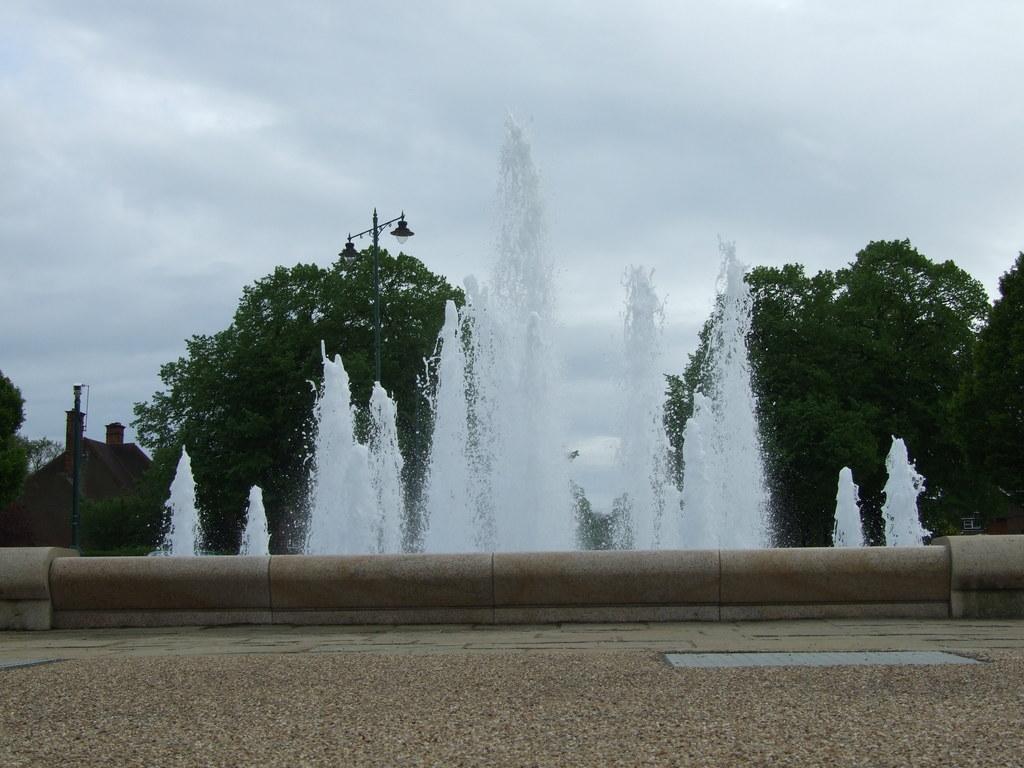Describe this image in one or two sentences. In this image in front there is a road. In the center of the image there is a fountain. There are trees. There are lights. On the left side of the image there is a building. In the background of the image there is sky. 